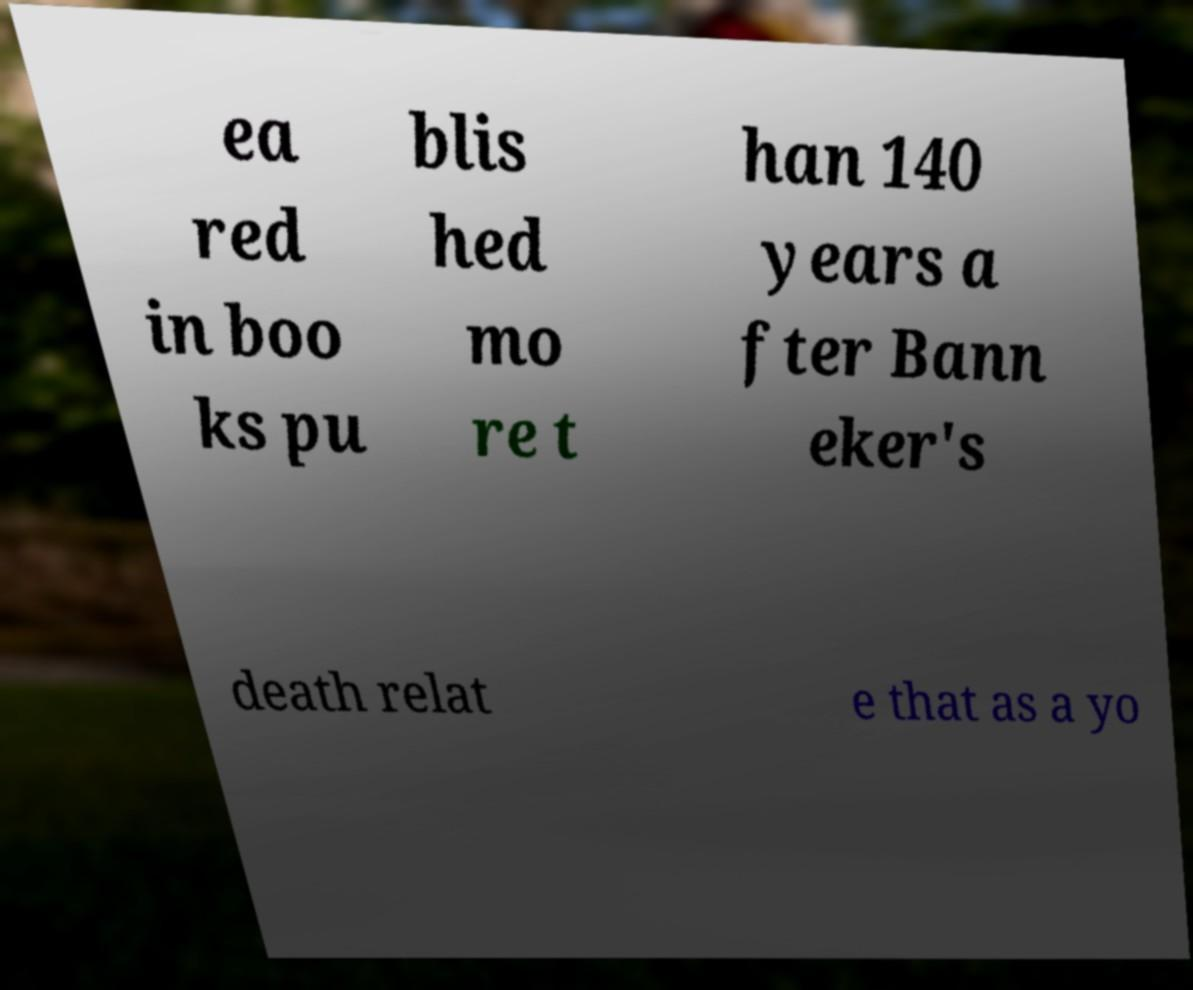I need the written content from this picture converted into text. Can you do that? ea red in boo ks pu blis hed mo re t han 140 years a fter Bann eker's death relat e that as a yo 